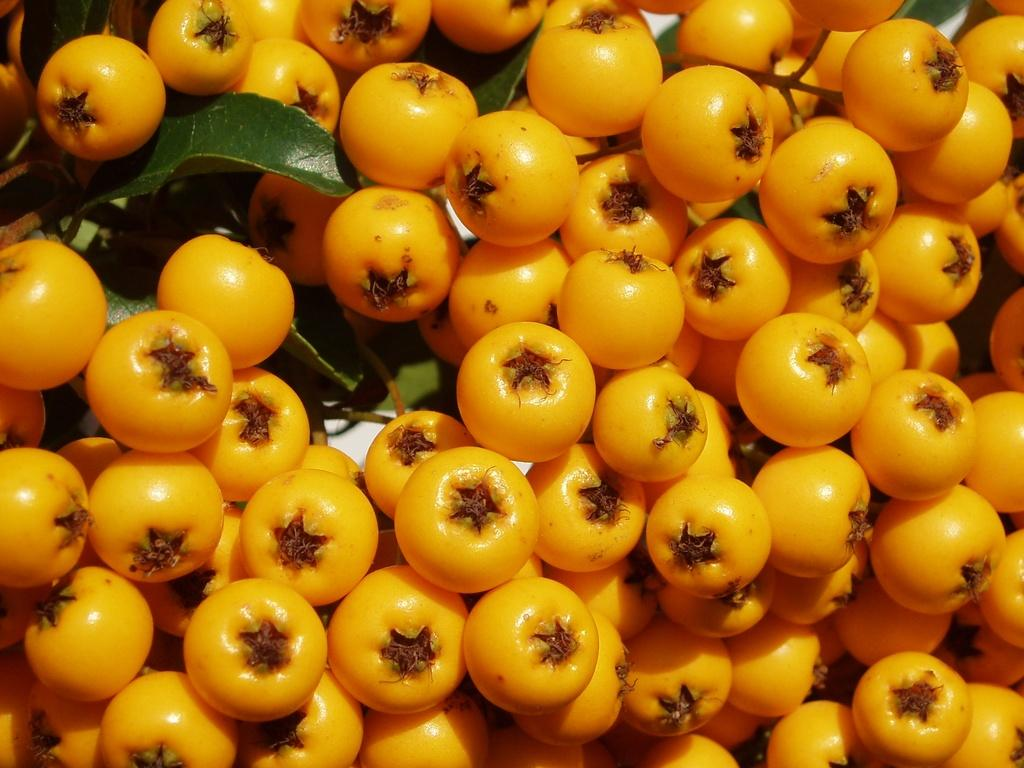What color are the tomatoes in the image? The tomatoes in the image are orange in color. What else can be seen in the image besides the tomatoes? There are leaves in the image. What type of voyage is depicted in the image? There is no voyage depicted in the image; it features tomatoes and leaves. Can you describe the error made by the tomatoes in the image? There is no error made by the tomatoes in the image; they are simply tomatoes of a specific color. 